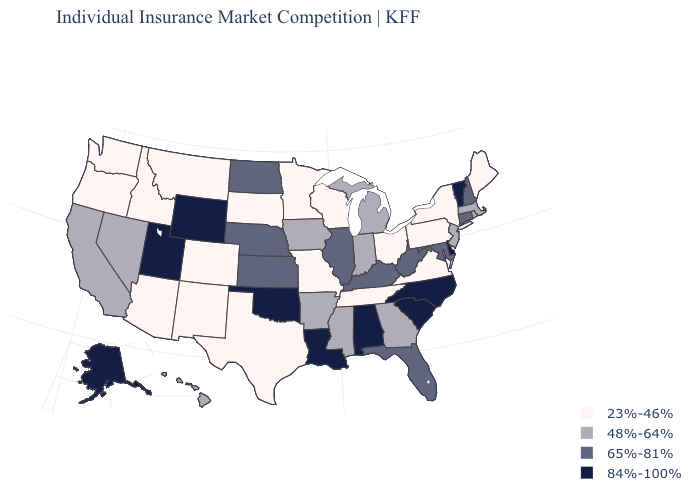What is the highest value in the USA?
Write a very short answer. 84%-100%. What is the value of Florida?
Short answer required. 65%-81%. What is the value of Iowa?
Give a very brief answer. 48%-64%. Among the states that border Oregon , which have the lowest value?
Give a very brief answer. Idaho, Washington. What is the lowest value in the USA?
Quick response, please. 23%-46%. Which states have the lowest value in the USA?
Write a very short answer. Arizona, Colorado, Idaho, Maine, Minnesota, Missouri, Montana, New Mexico, New York, Ohio, Oregon, Pennsylvania, South Dakota, Tennessee, Texas, Virginia, Washington, Wisconsin. Among the states that border Oregon , does Nevada have the lowest value?
Short answer required. No. Does the map have missing data?
Give a very brief answer. No. Which states have the lowest value in the USA?
Write a very short answer. Arizona, Colorado, Idaho, Maine, Minnesota, Missouri, Montana, New Mexico, New York, Ohio, Oregon, Pennsylvania, South Dakota, Tennessee, Texas, Virginia, Washington, Wisconsin. Does Maine have the highest value in the USA?
Quick response, please. No. Name the states that have a value in the range 84%-100%?
Keep it brief. Alabama, Alaska, Delaware, Louisiana, North Carolina, Oklahoma, South Carolina, Utah, Vermont, Wyoming. What is the lowest value in the Northeast?
Write a very short answer. 23%-46%. Name the states that have a value in the range 23%-46%?
Be succinct. Arizona, Colorado, Idaho, Maine, Minnesota, Missouri, Montana, New Mexico, New York, Ohio, Oregon, Pennsylvania, South Dakota, Tennessee, Texas, Virginia, Washington, Wisconsin. What is the highest value in states that border Maryland?
Quick response, please. 84%-100%. What is the value of South Carolina?
Short answer required. 84%-100%. 